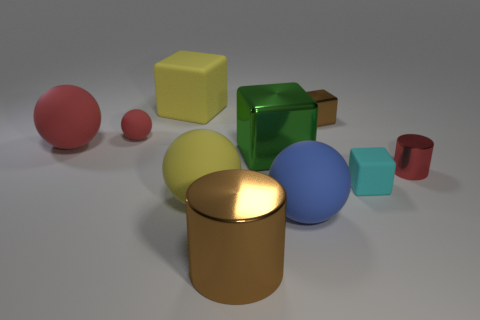Subtract all tiny red balls. How many balls are left? 3 Subtract all red balls. How many were subtracted if there are1red balls left? 1 Subtract 2 balls. How many balls are left? 2 Subtract all gray spheres. Subtract all green cylinders. How many spheres are left? 4 Subtract all purple blocks. How many blue balls are left? 1 Subtract all green objects. Subtract all big blue spheres. How many objects are left? 8 Add 6 tiny rubber balls. How many tiny rubber balls are left? 7 Add 6 cyan rubber objects. How many cyan rubber objects exist? 7 Subtract all green blocks. How many blocks are left? 3 Subtract 1 cyan cubes. How many objects are left? 9 